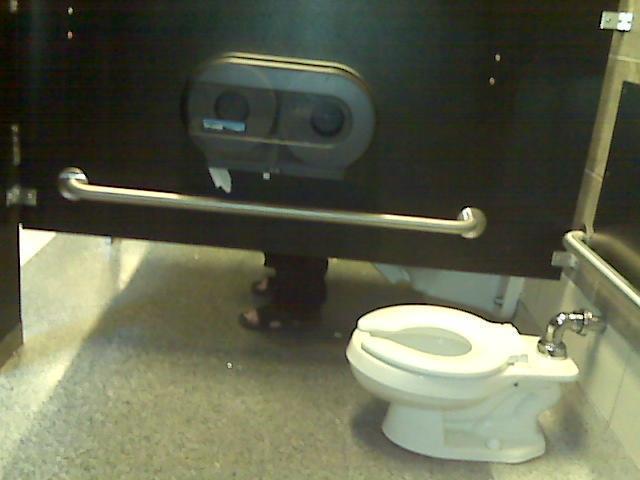How many rolls of toilet paper?
Give a very brief answer. 2. How many toilets can you see?
Give a very brief answer. 2. 